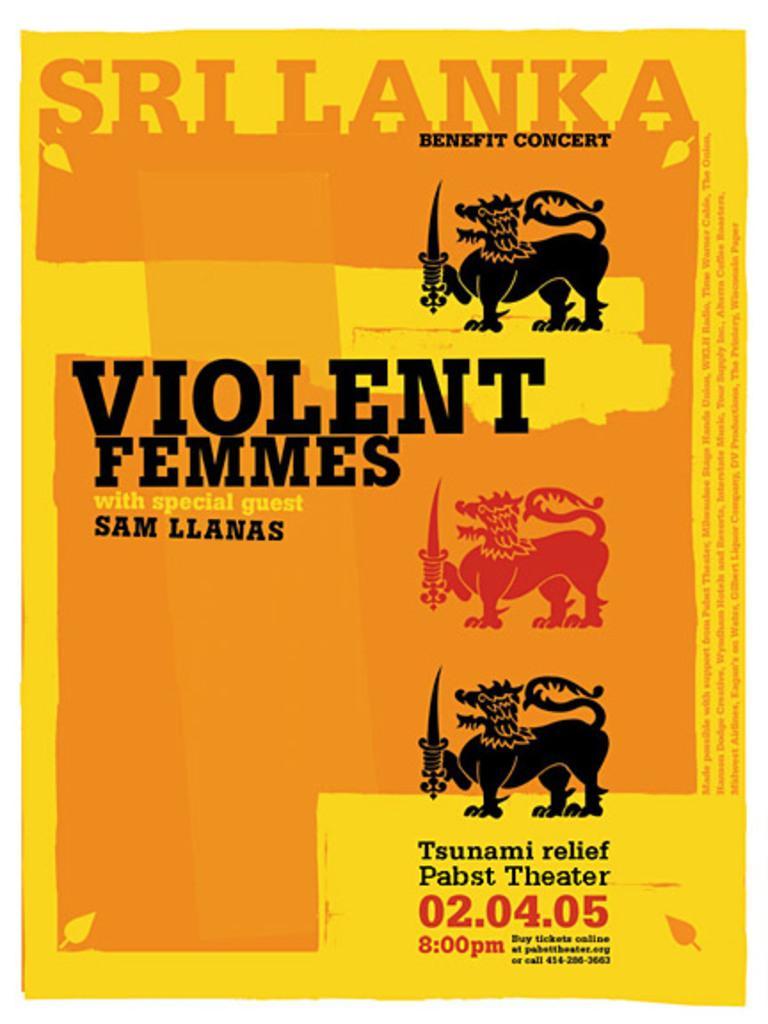Can you describe this image briefly? In this picture we can see a poster, here we can see animals holding swords, leaves, some text and some numbers on it. 